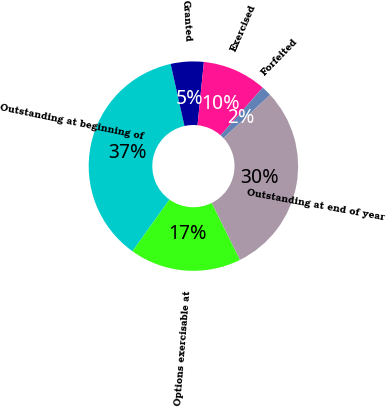<chart> <loc_0><loc_0><loc_500><loc_500><pie_chart><fcel>Outstanding at beginning of<fcel>Granted<fcel>Exercised<fcel>Forfeited<fcel>Outstanding at end of year<fcel>Options exercisable at<nl><fcel>36.63%<fcel>5.08%<fcel>9.92%<fcel>1.57%<fcel>29.59%<fcel>17.2%<nl></chart> 